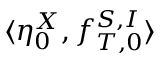Convert formula to latex. <formula><loc_0><loc_0><loc_500><loc_500>\langle \eta _ { 0 } ^ { X } , f _ { T , 0 } ^ { S , I } \rangle</formula> 